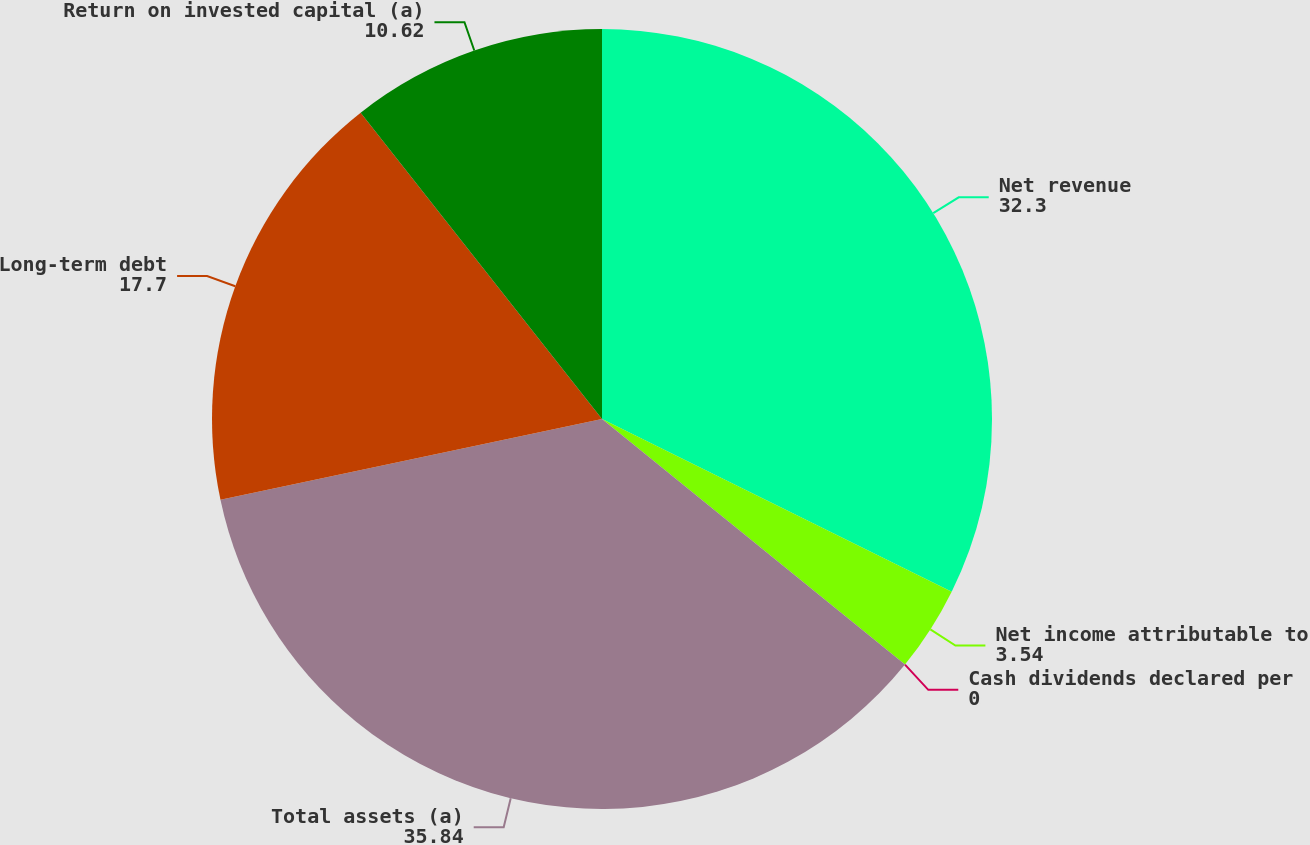<chart> <loc_0><loc_0><loc_500><loc_500><pie_chart><fcel>Net revenue<fcel>Net income attributable to<fcel>Cash dividends declared per<fcel>Total assets (a)<fcel>Long-term debt<fcel>Return on invested capital (a)<nl><fcel>32.3%<fcel>3.54%<fcel>0.0%<fcel>35.84%<fcel>17.7%<fcel>10.62%<nl></chart> 